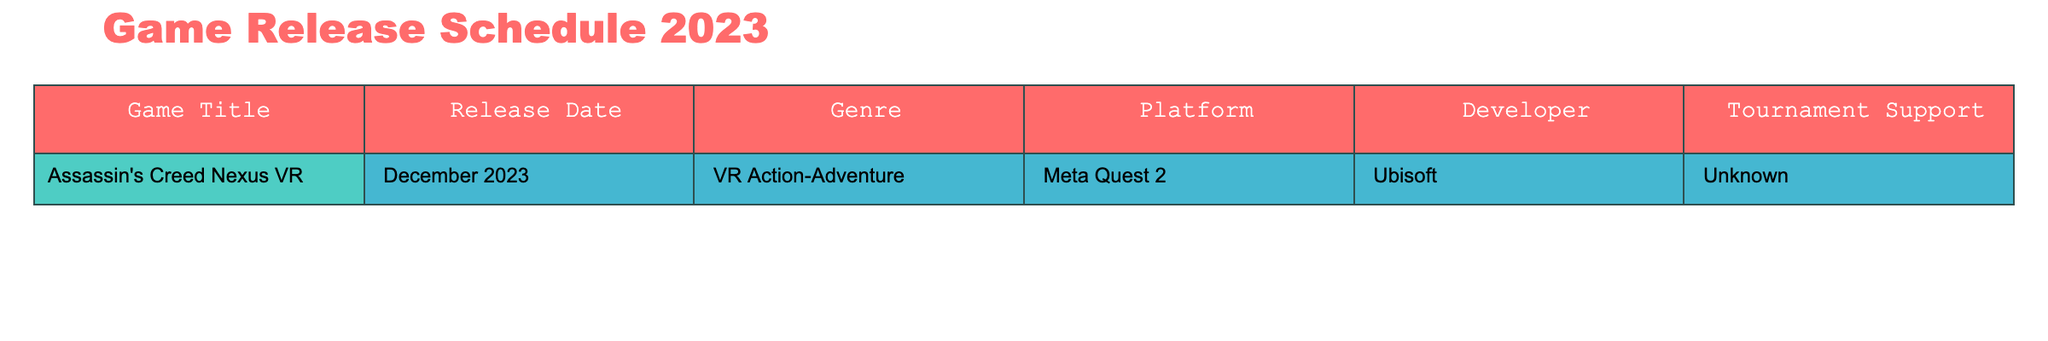What is the release date of Assassin's Creed Nexus VR? The release date is listed in the table for Assassin's Creed Nexus VR, which is December 2023.
Answer: December 2023 What genre does Assassin's Creed Nexus VR belong to? The genre is specified in the table, which states that Assassin's Creed Nexus VR is a VR Action-Adventure game.
Answer: VR Action-Adventure Which platform is Assassin's Creed Nexus VR available on? The platform on which the game is available is indicated in the table; it states that it is for Meta Quest 2.
Answer: Meta Quest 2 Is there any tournament support for Assassin's Creed Nexus VR? The table shows that the tournament support for this game is listed as "Unknown," meaning it's unclear if there will be tournaments for it.
Answer: Unknown What is the developer of Assassin's Creed Nexus VR? The developer of the game is provided in the table, which identifies Ubisoft as the developer.
Answer: Ubisoft Can you identify any game released in December 2023? According to the table, the only game listed for December 2023 is Assassin's Creed Nexus VR.
Answer: Assassin's Creed Nexus VR If a game is designated as "VR Action-Adventure," does it mean it supports tournaments? The table shows that while the game is categorized under VR Action-Adventure, its tournament support is marked as "Unknown," meaning it does not confirm tournament support.
Answer: No Based on the data, does Ubisoft develop any games scheduled for December 2023? Looking at the table, since Ubisoft is the developer of Assassin's Creed Nexus VR and it is scheduled for December 2023, the answer is yes.
Answer: Yes What can we conclude about the genre of games with unknown tournament support based on the table? The table contains only one entry, which is VR Action-Adventure with unknown tournament support, so we cannot make broad conclusions beyond that single entry.
Answer: Cannot conclude What is the relationship between the release date of Assassin's Creed Nexus VR and its genre? The table shows that the release date is December 2023 and the genre is VR Action-Adventure, but no direct relationship is defined in the table regarding dates and genres. Therefore, we can only say they are attributes of the same game.
Answer: They relate to the same game 